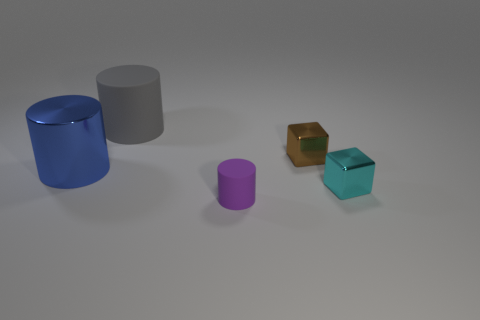Subtract all tiny purple cylinders. How many cylinders are left? 2 Add 3 gray objects. How many objects exist? 8 Subtract all blocks. How many objects are left? 3 Subtract 1 purple cylinders. How many objects are left? 4 Subtract all green cylinders. Subtract all brown balls. How many cylinders are left? 3 Subtract all large gray cylinders. Subtract all small brown cylinders. How many objects are left? 4 Add 1 tiny brown things. How many tiny brown things are left? 2 Add 1 brown metal spheres. How many brown metal spheres exist? 1 